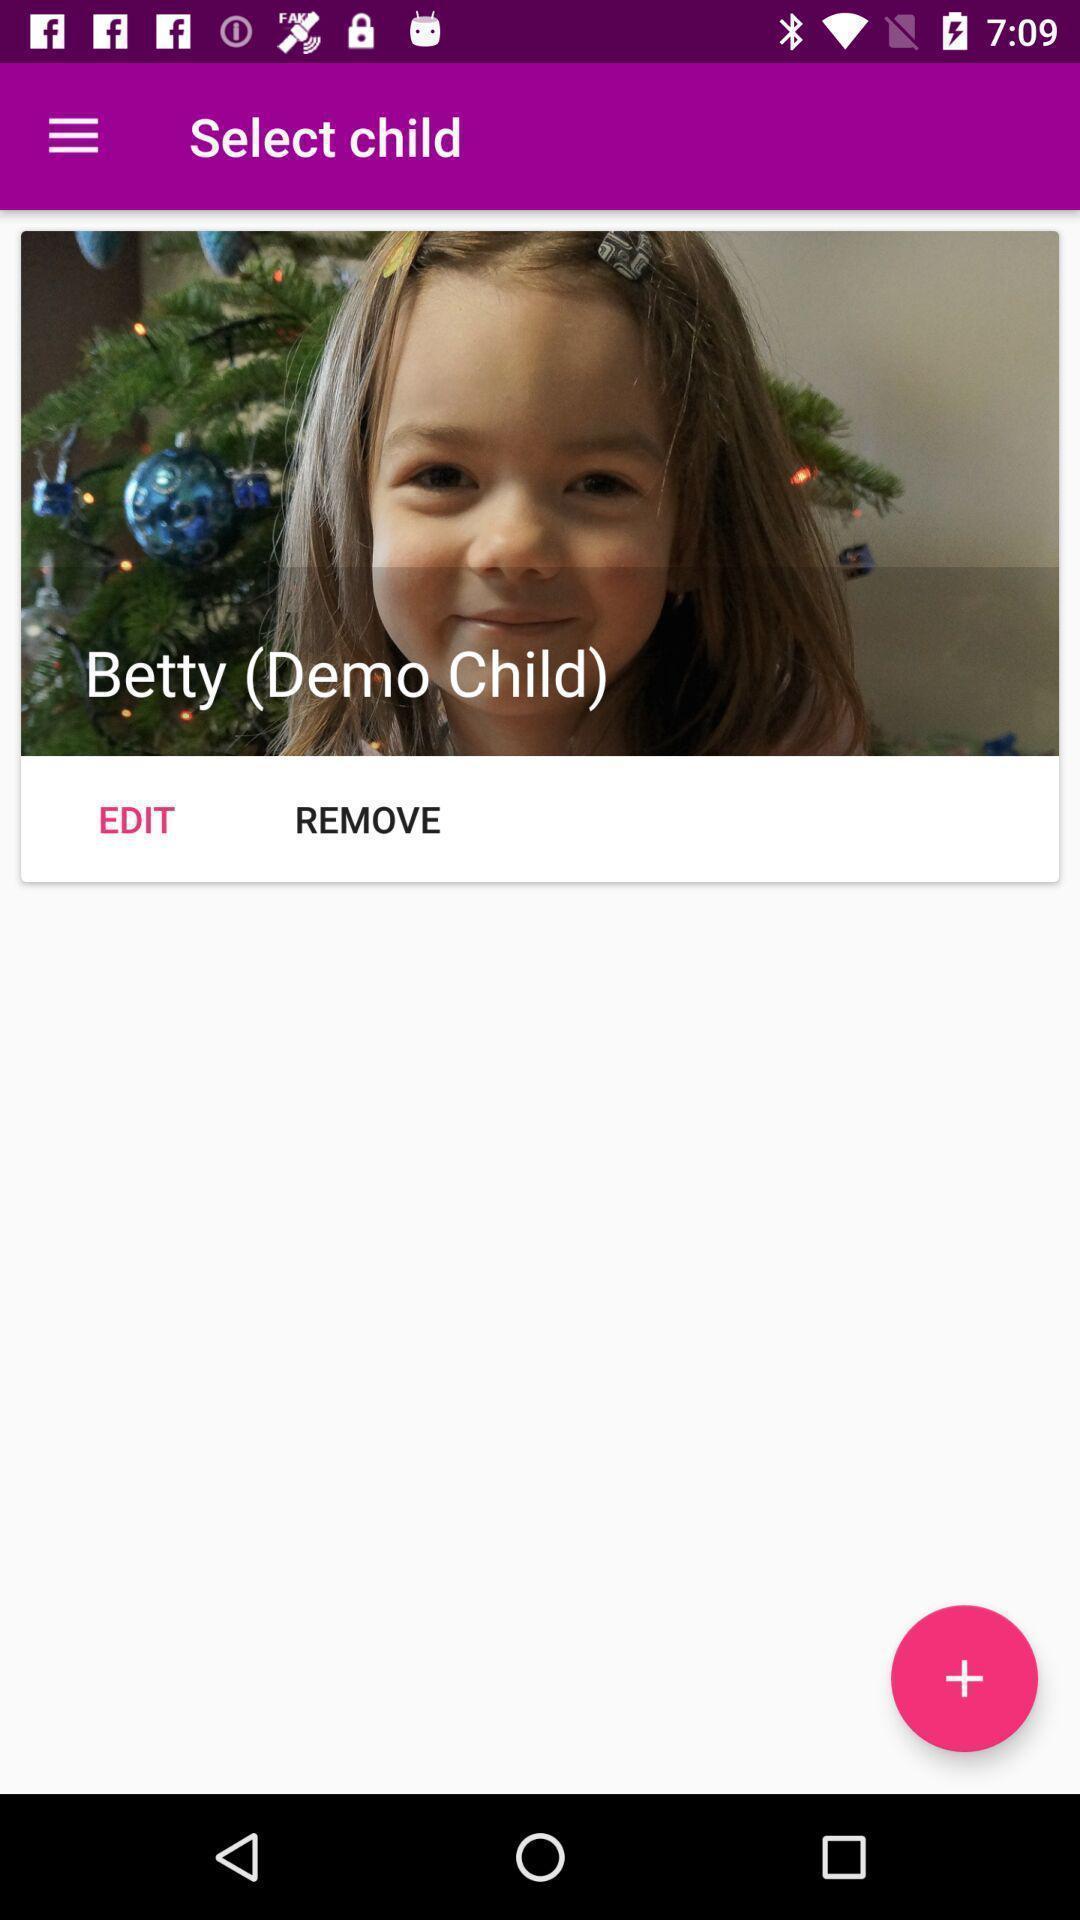Summarize the information in this screenshot. Select child in photo edit. 